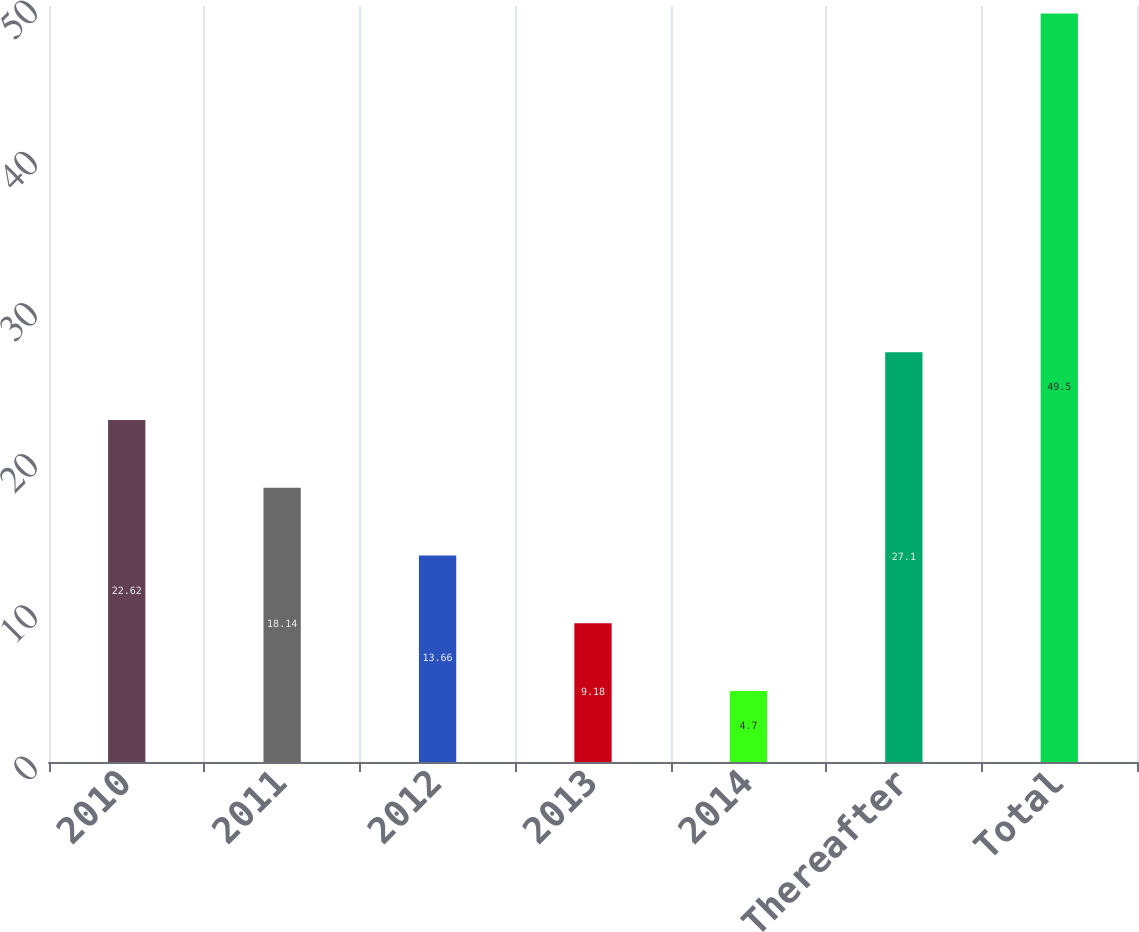Convert chart. <chart><loc_0><loc_0><loc_500><loc_500><bar_chart><fcel>2010<fcel>2011<fcel>2012<fcel>2013<fcel>2014<fcel>Thereafter<fcel>Total<nl><fcel>22.62<fcel>18.14<fcel>13.66<fcel>9.18<fcel>4.7<fcel>27.1<fcel>49.5<nl></chart> 